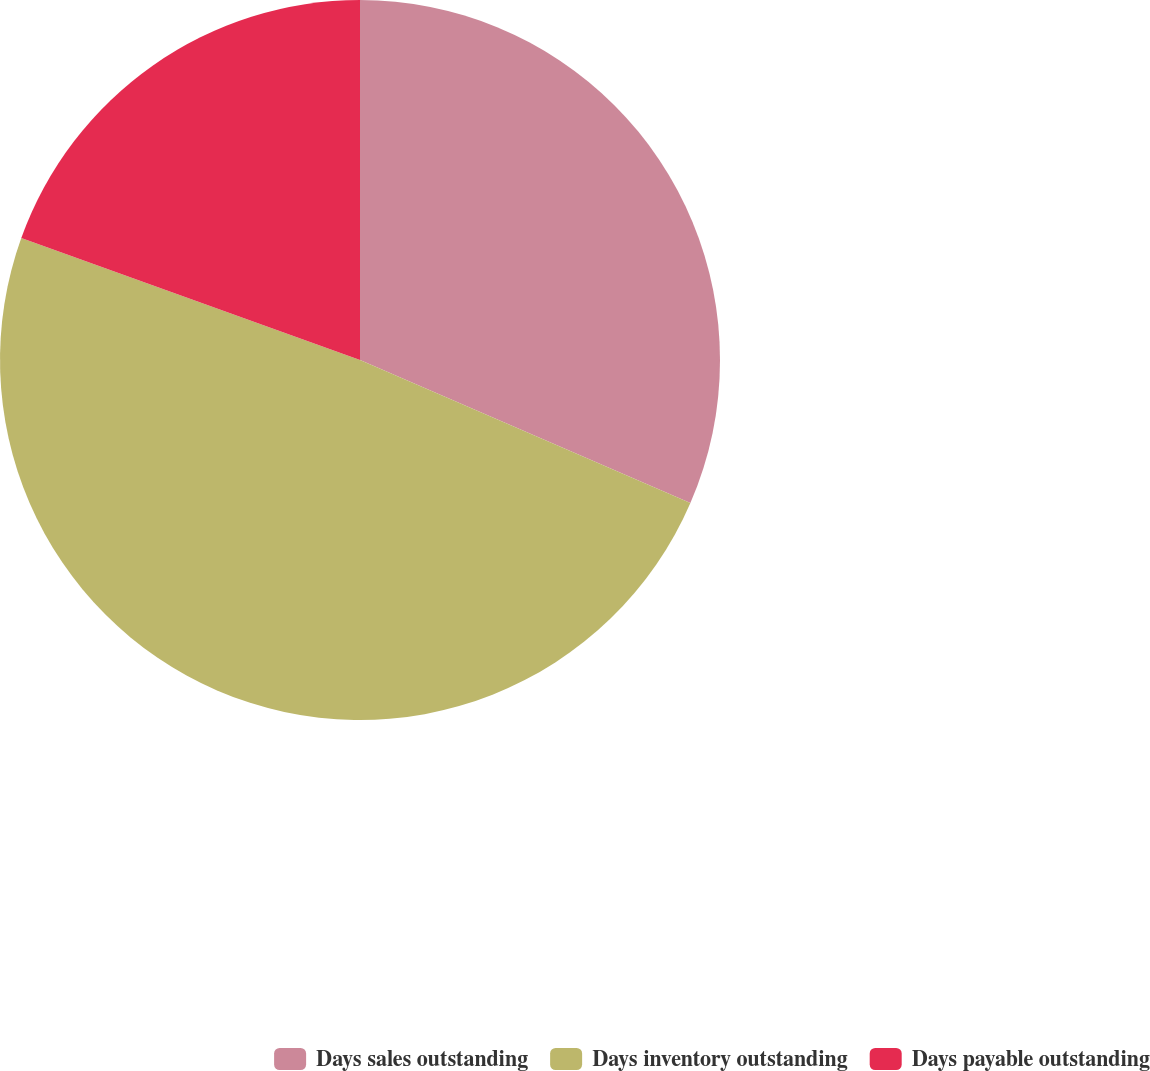Convert chart. <chart><loc_0><loc_0><loc_500><loc_500><pie_chart><fcel>Days sales outstanding<fcel>Days inventory outstanding<fcel>Days payable outstanding<nl><fcel>31.5%<fcel>49.0%<fcel>19.5%<nl></chart> 